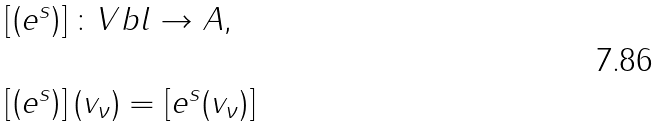<formula> <loc_0><loc_0><loc_500><loc_500>\begin{array} { l l } \left [ \left ( e ^ { s } \right ) \right ] \colon V b l \rightarrow A , \\ \\ \left [ \left ( e ^ { s } \right ) \right ] ( v _ { \nu } ) = \left [ e ^ { s } ( v _ { \nu } ) \right ] \end{array}</formula> 